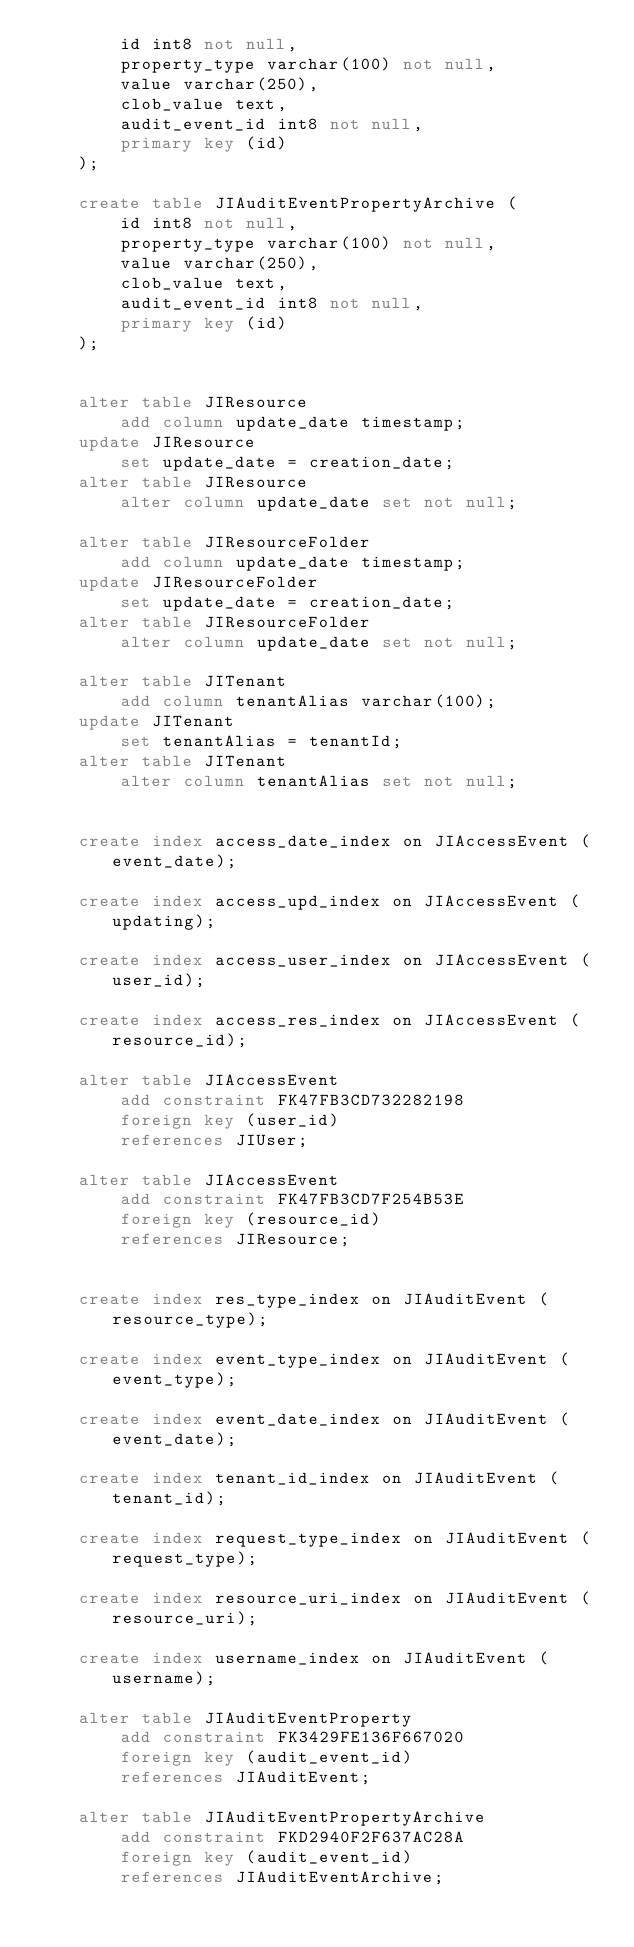<code> <loc_0><loc_0><loc_500><loc_500><_SQL_>        id int8 not null,
        property_type varchar(100) not null,
        value varchar(250),
        clob_value text,
        audit_event_id int8 not null,
        primary key (id)
    );

    create table JIAuditEventPropertyArchive (
        id int8 not null,
        property_type varchar(100) not null,
        value varchar(250),
        clob_value text,
        audit_event_id int8 not null,
        primary key (id)
    );


    alter table JIResource
        add column update_date timestamp;
    update JIResource
        set update_date = creation_date;
    alter table JIResource
        alter column update_date set not null;
        
    alter table JIResourceFolder
        add column update_date timestamp;
    update JIResourceFolder
        set update_date = creation_date;
    alter table JIResourceFolder
        alter column update_date set not null;

    alter table JITenant
        add column tenantAlias varchar(100);
    update JITenant
        set tenantAlias = tenantId;
    alter table JITenant
        alter column tenantAlias set not null;
        

    create index access_date_index on JIAccessEvent (event_date);

    create index access_upd_index on JIAccessEvent (updating);

    create index access_user_index on JIAccessEvent (user_id);

    create index access_res_index on JIAccessEvent (resource_id);

    alter table JIAccessEvent 
        add constraint FK47FB3CD732282198 
        foreign key (user_id) 
        references JIUser;

    alter table JIAccessEvent 
        add constraint FK47FB3CD7F254B53E 
        foreign key (resource_id) 
        references JIResource;


    create index res_type_index on JIAuditEvent (resource_type);

    create index event_type_index on JIAuditEvent (event_type);

    create index event_date_index on JIAuditEvent (event_date);

    create index tenant_id_index on JIAuditEvent (tenant_id);

    create index request_type_index on JIAuditEvent (request_type);

    create index resource_uri_index on JIAuditEvent (resource_uri);

    create index username_index on JIAuditEvent (username);

    alter table JIAuditEventProperty 
        add constraint FK3429FE136F667020 
        foreign key (audit_event_id) 
        references JIAuditEvent;

    alter table JIAuditEventPropertyArchive 
        add constraint FKD2940F2F637AC28A 
        foreign key (audit_event_id) 
        references JIAuditEventArchive;
</code> 